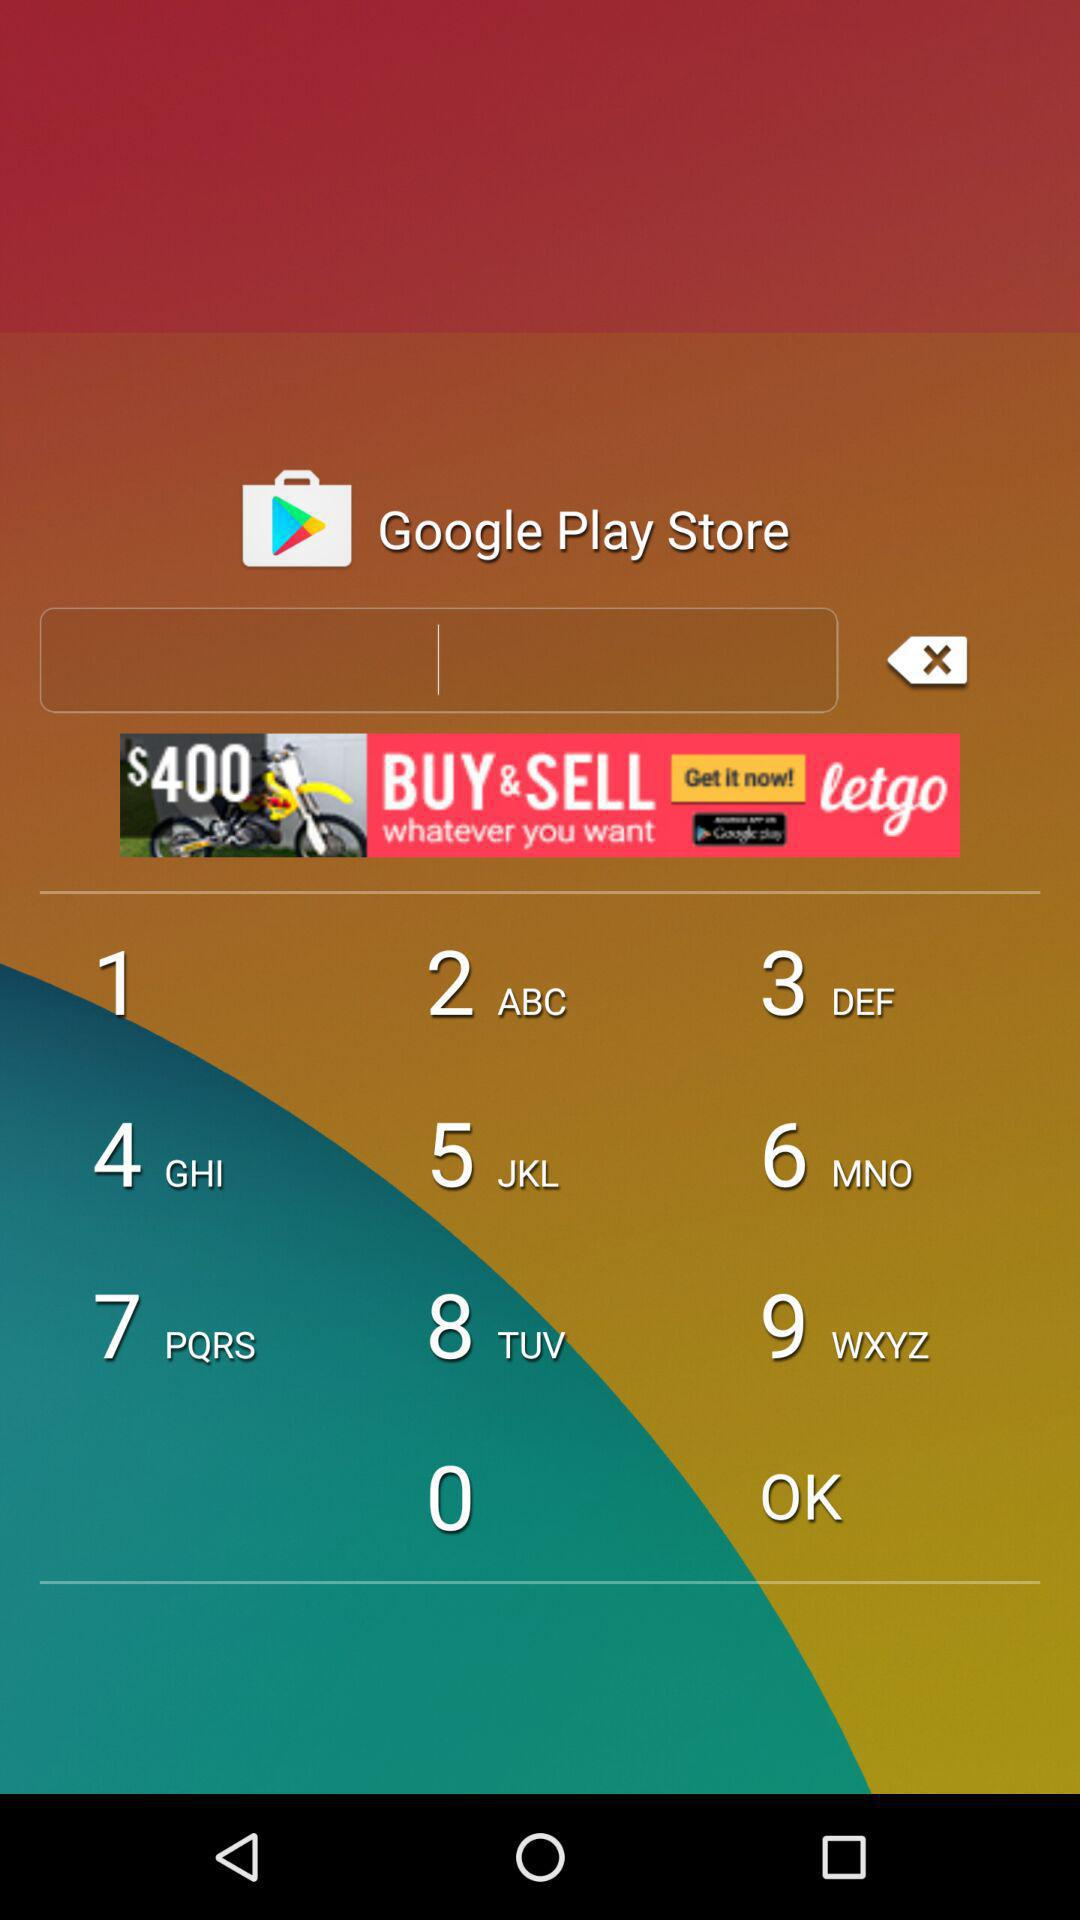What is the current status of the "Show all"? The current status is "on". 